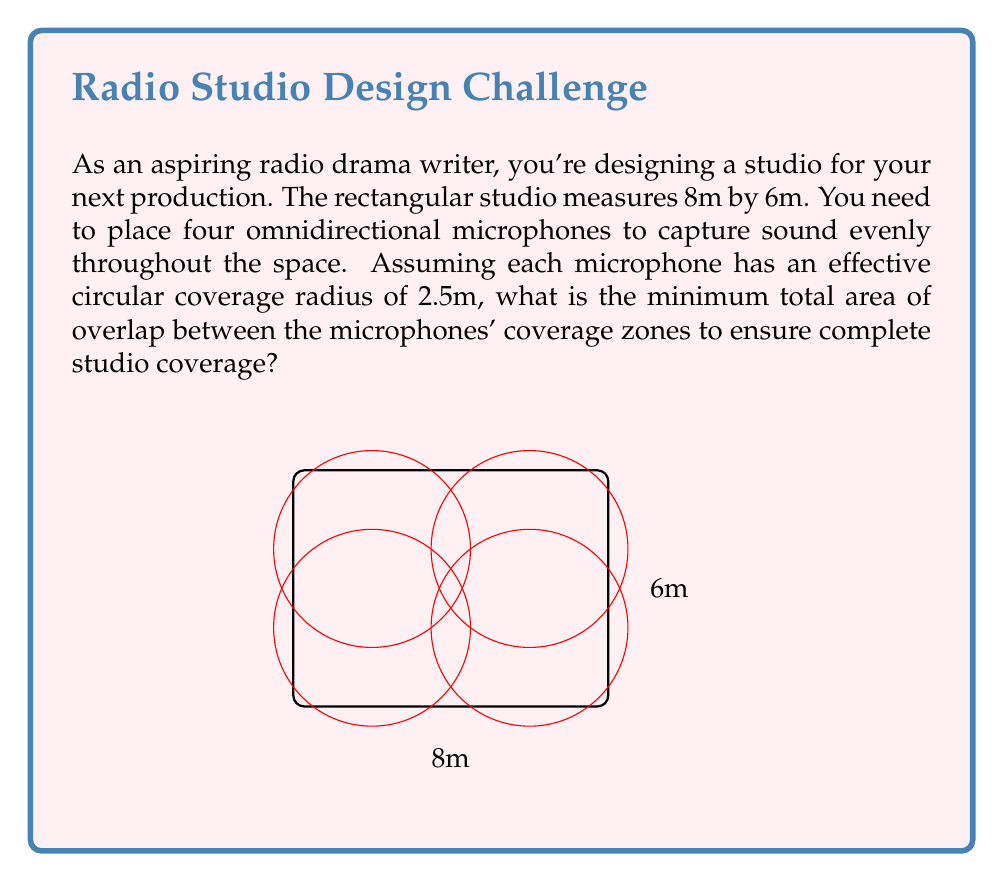Help me with this question. Let's approach this step-by-step:

1) First, we need to calculate the total area of the studio:
   $A_{studio} = 8m \times 6m = 48m^2$

2) Each microphone covers a circular area with radius 2.5m. The area of each circle is:
   $A_{mic} = \pi r^2 = \pi (2.5m)^2 = 19.63m^2$

3) The total area covered by all four microphones without considering overlap is:
   $A_{total} = 4 \times 19.63m^2 = 78.54m^2$

4) To find the overlap, we subtract the studio area from the total area covered:
   $A_{overlap} = A_{total} - A_{studio} = 78.54m^2 - 48m^2 = 30.54m^2$

5) However, this includes areas where more than two microphones overlap. We need to find the minimum overlap required for complete coverage.

6) The optimal arrangement is to place the microphones in the corners of a rectangle, with their coverage circles just touching in the center of the studio.

7) In this arrangement, there are four areas of overlap between pairs of microphones, and one central area where all four overlap.

8) The area of overlap between two circles can be calculated using the formula:
   $A_{2overlap} = 2r^2 \arccos(\frac{d}{2r}) - d\sqrt{r^2 - \frac{d^2}{4}}$
   where $r$ is the radius (2.5m) and $d$ is the distance between circle centers.

9) In our case, $d = \sqrt{4^2 + 2^2} = \sqrt{20} = 4.47m$

10) Plugging this into the formula:
    $A_{2overlap} = 2(2.5^2) \arccos(\frac{4.47}{2(2.5)}) - 4.47\sqrt{2.5^2 - \frac{4.47^2}{4}} = 1.92m^2$

11) There are four such overlaps, so the total minimum overlap area is:
    $A_{min\_overlap} = 4 \times 1.92m^2 = 7.68m^2$
Answer: $7.68m^2$ 